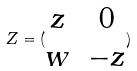<formula> <loc_0><loc_0><loc_500><loc_500>Z = ( \begin{matrix} z & 0 \\ w & - z \end{matrix} )</formula> 